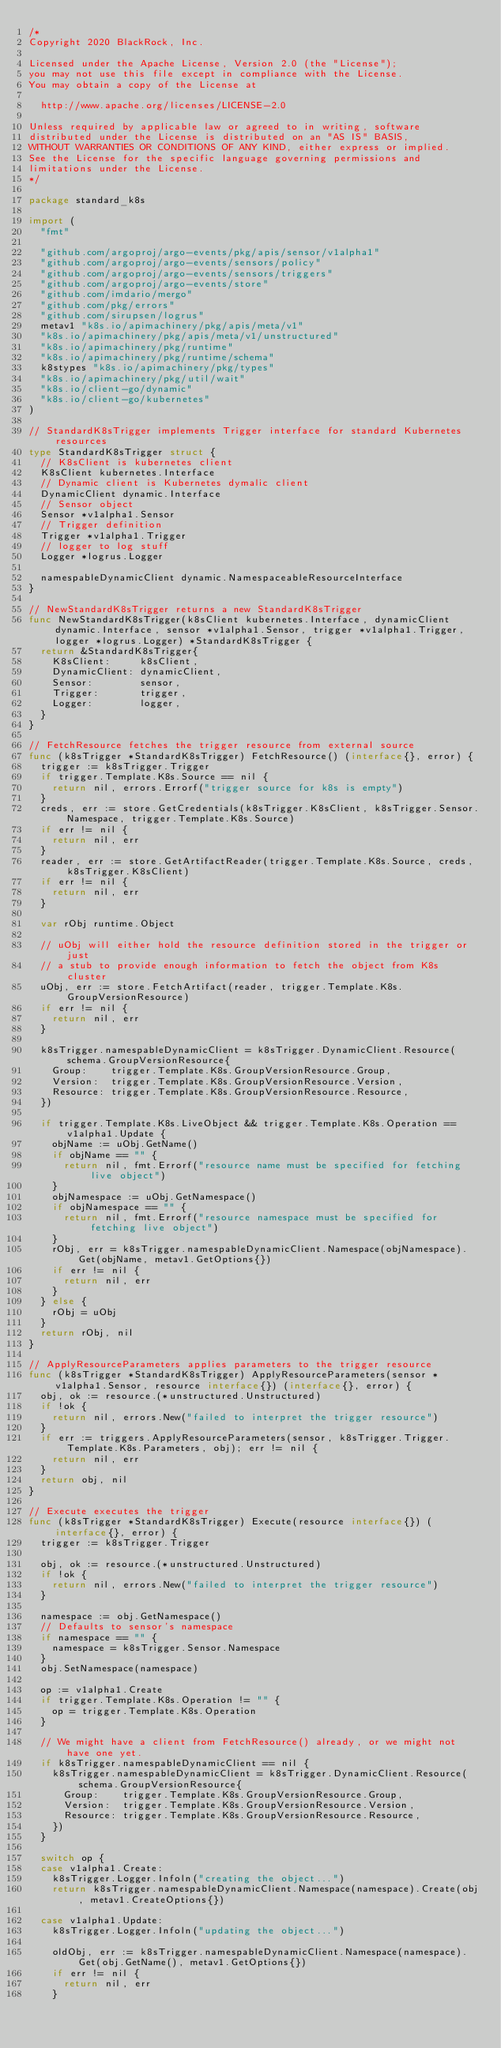Convert code to text. <code><loc_0><loc_0><loc_500><loc_500><_Go_>/*
Copyright 2020 BlackRock, Inc.

Licensed under the Apache License, Version 2.0 (the "License");
you may not use this file except in compliance with the License.
You may obtain a copy of the License at

	http://www.apache.org/licenses/LICENSE-2.0

Unless required by applicable law or agreed to in writing, software
distributed under the License is distributed on an "AS IS" BASIS,
WITHOUT WARRANTIES OR CONDITIONS OF ANY KIND, either express or implied.
See the License for the specific language governing permissions and
limitations under the License.
*/

package standard_k8s

import (
	"fmt"

	"github.com/argoproj/argo-events/pkg/apis/sensor/v1alpha1"
	"github.com/argoproj/argo-events/sensors/policy"
	"github.com/argoproj/argo-events/sensors/triggers"
	"github.com/argoproj/argo-events/store"
	"github.com/imdario/mergo"
	"github.com/pkg/errors"
	"github.com/sirupsen/logrus"
	metav1 "k8s.io/apimachinery/pkg/apis/meta/v1"
	"k8s.io/apimachinery/pkg/apis/meta/v1/unstructured"
	"k8s.io/apimachinery/pkg/runtime"
	"k8s.io/apimachinery/pkg/runtime/schema"
	k8stypes "k8s.io/apimachinery/pkg/types"
	"k8s.io/apimachinery/pkg/util/wait"
	"k8s.io/client-go/dynamic"
	"k8s.io/client-go/kubernetes"
)

// StandardK8sTrigger implements Trigger interface for standard Kubernetes resources
type StandardK8sTrigger struct {
	// K8sClient is kubernetes client
	K8sClient kubernetes.Interface
	// Dynamic client is Kubernetes dymalic client
	DynamicClient dynamic.Interface
	// Sensor object
	Sensor *v1alpha1.Sensor
	// Trigger definition
	Trigger *v1alpha1.Trigger
	// logger to log stuff
	Logger *logrus.Logger

	namespableDynamicClient dynamic.NamespaceableResourceInterface
}

// NewStandardK8sTrigger returns a new StandardK8sTrigger
func NewStandardK8sTrigger(k8sClient kubernetes.Interface, dynamicClient dynamic.Interface, sensor *v1alpha1.Sensor, trigger *v1alpha1.Trigger, logger *logrus.Logger) *StandardK8sTrigger {
	return &StandardK8sTrigger{
		K8sClient:     k8sClient,
		DynamicClient: dynamicClient,
		Sensor:        sensor,
		Trigger:       trigger,
		Logger:        logger,
	}
}

// FetchResource fetches the trigger resource from external source
func (k8sTrigger *StandardK8sTrigger) FetchResource() (interface{}, error) {
	trigger := k8sTrigger.Trigger
	if trigger.Template.K8s.Source == nil {
		return nil, errors.Errorf("trigger source for k8s is empty")
	}
	creds, err := store.GetCredentials(k8sTrigger.K8sClient, k8sTrigger.Sensor.Namespace, trigger.Template.K8s.Source)
	if err != nil {
		return nil, err
	}
	reader, err := store.GetArtifactReader(trigger.Template.K8s.Source, creds, k8sTrigger.K8sClient)
	if err != nil {
		return nil, err
	}

	var rObj runtime.Object

	// uObj will either hold the resource definition stored in the trigger or just
	// a stub to provide enough information to fetch the object from K8s cluster
	uObj, err := store.FetchArtifact(reader, trigger.Template.K8s.GroupVersionResource)
	if err != nil {
		return nil, err
	}

	k8sTrigger.namespableDynamicClient = k8sTrigger.DynamicClient.Resource(schema.GroupVersionResource{
		Group:    trigger.Template.K8s.GroupVersionResource.Group,
		Version:  trigger.Template.K8s.GroupVersionResource.Version,
		Resource: trigger.Template.K8s.GroupVersionResource.Resource,
	})

	if trigger.Template.K8s.LiveObject && trigger.Template.K8s.Operation == v1alpha1.Update {
		objName := uObj.GetName()
		if objName == "" {
			return nil, fmt.Errorf("resource name must be specified for fetching live object")
		}
		objNamespace := uObj.GetNamespace()
		if objNamespace == "" {
			return nil, fmt.Errorf("resource namespace must be specified for fetching live object")
		}
		rObj, err = k8sTrigger.namespableDynamicClient.Namespace(objNamespace).Get(objName, metav1.GetOptions{})
		if err != nil {
			return nil, err
		}
	} else {
		rObj = uObj
	}
	return rObj, nil
}

// ApplyResourceParameters applies parameters to the trigger resource
func (k8sTrigger *StandardK8sTrigger) ApplyResourceParameters(sensor *v1alpha1.Sensor, resource interface{}) (interface{}, error) {
	obj, ok := resource.(*unstructured.Unstructured)
	if !ok {
		return nil, errors.New("failed to interpret the trigger resource")
	}
	if err := triggers.ApplyResourceParameters(sensor, k8sTrigger.Trigger.Template.K8s.Parameters, obj); err != nil {
		return nil, err
	}
	return obj, nil
}

// Execute executes the trigger
func (k8sTrigger *StandardK8sTrigger) Execute(resource interface{}) (interface{}, error) {
	trigger := k8sTrigger.Trigger

	obj, ok := resource.(*unstructured.Unstructured)
	if !ok {
		return nil, errors.New("failed to interpret the trigger resource")
	}

	namespace := obj.GetNamespace()
	// Defaults to sensor's namespace
	if namespace == "" {
		namespace = k8sTrigger.Sensor.Namespace
	}
	obj.SetNamespace(namespace)

	op := v1alpha1.Create
	if trigger.Template.K8s.Operation != "" {
		op = trigger.Template.K8s.Operation
	}

	// We might have a client from FetchResource() already, or we might not have one yet.
	if k8sTrigger.namespableDynamicClient == nil {
		k8sTrigger.namespableDynamicClient = k8sTrigger.DynamicClient.Resource(schema.GroupVersionResource{
			Group:    trigger.Template.K8s.GroupVersionResource.Group,
			Version:  trigger.Template.K8s.GroupVersionResource.Version,
			Resource: trigger.Template.K8s.GroupVersionResource.Resource,
		})
	}

	switch op {
	case v1alpha1.Create:
		k8sTrigger.Logger.Infoln("creating the object...")
		return k8sTrigger.namespableDynamicClient.Namespace(namespace).Create(obj, metav1.CreateOptions{})

	case v1alpha1.Update:
		k8sTrigger.Logger.Infoln("updating the object...")

		oldObj, err := k8sTrigger.namespableDynamicClient.Namespace(namespace).Get(obj.GetName(), metav1.GetOptions{})
		if err != nil {
			return nil, err
		}
</code> 